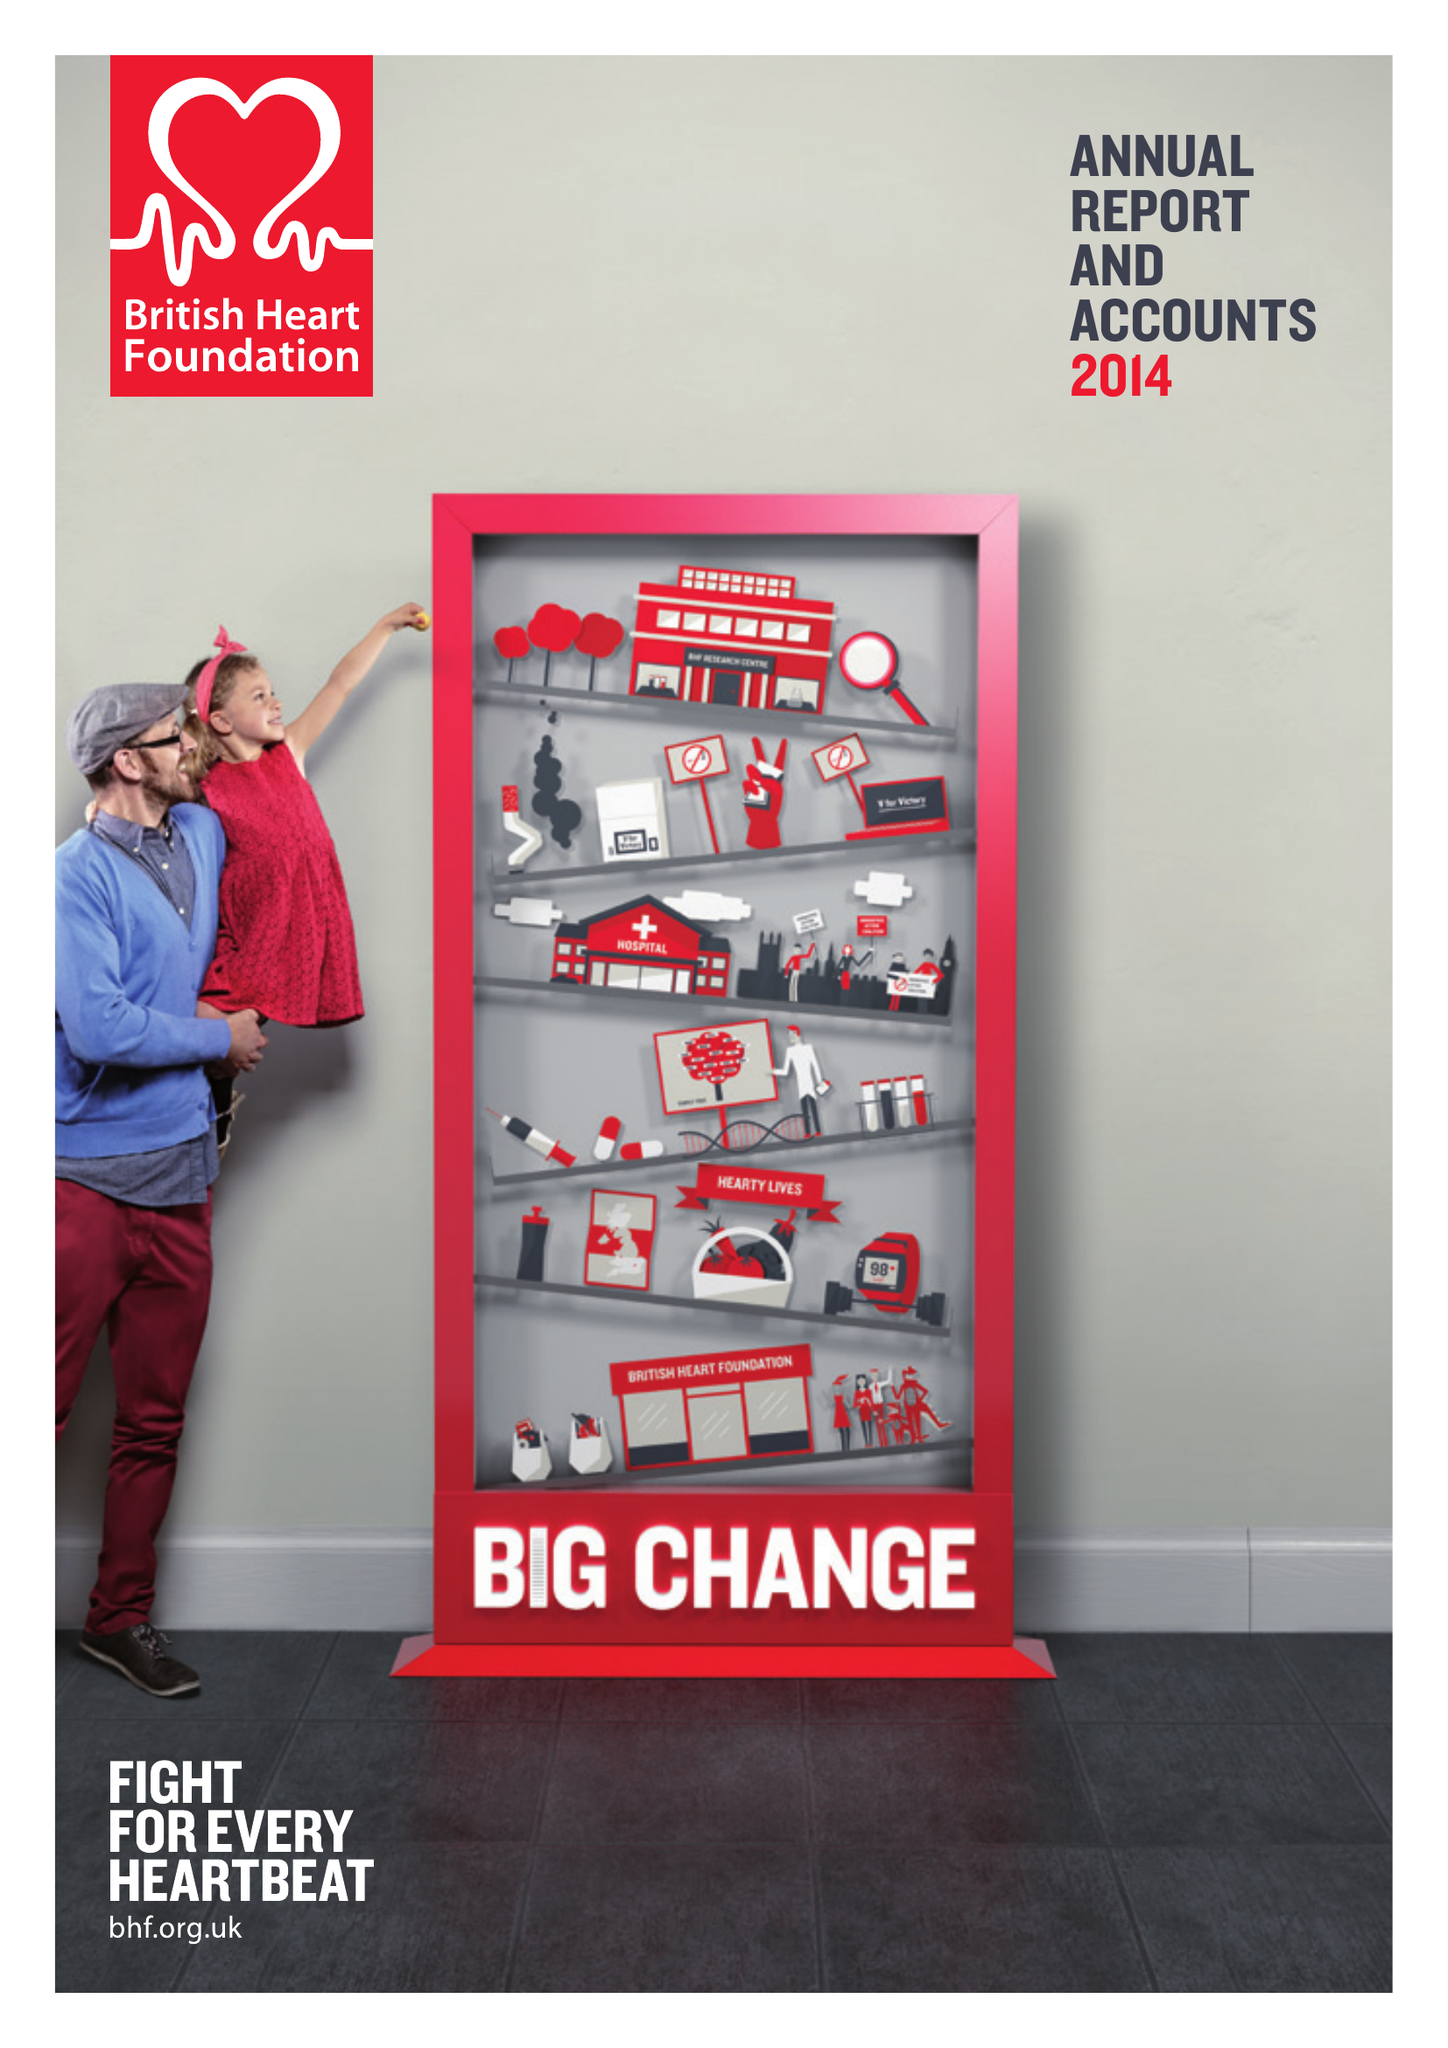What is the value for the spending_annually_in_british_pounds?
Answer the question using a single word or phrase. 312800000.00 